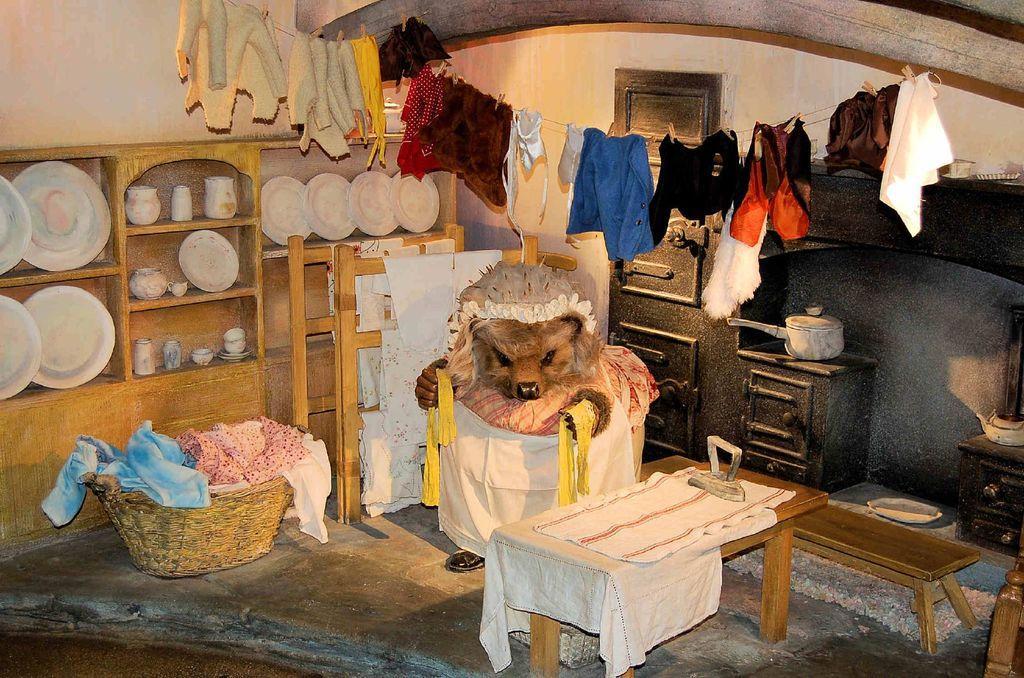Could you give a brief overview of what you see in this image? There is a room in which we can observe an animal here. There is a basket in which a clothes are placed. And plates are placed in a cupboard here. Clothes were hanged on a rope. We can observe a table here. 